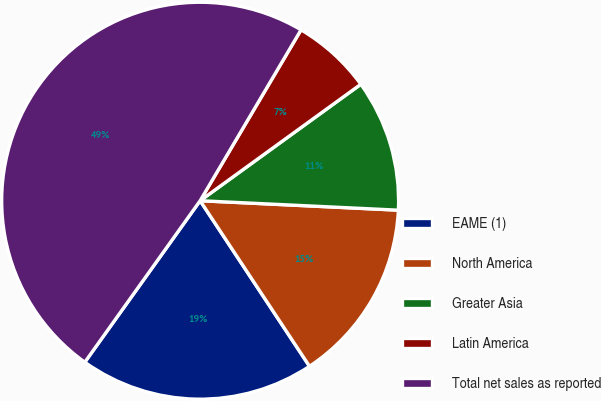Convert chart. <chart><loc_0><loc_0><loc_500><loc_500><pie_chart><fcel>EAME (1)<fcel>North America<fcel>Greater Asia<fcel>Latin America<fcel>Total net sales as reported<nl><fcel>19.16%<fcel>14.95%<fcel>10.74%<fcel>6.53%<fcel>48.62%<nl></chart> 